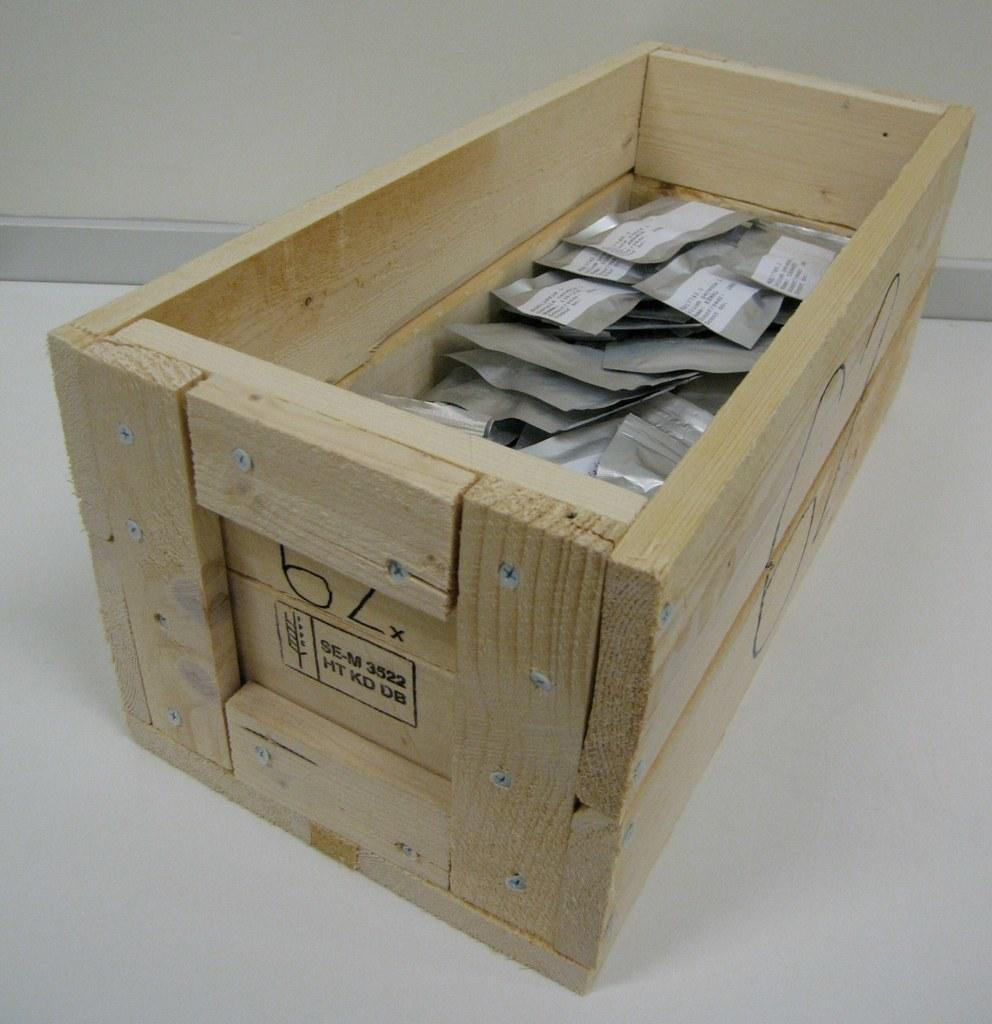<image>
Relay a brief, clear account of the picture shown. A wooden crate that is stamped with the identifier SE-M 3522, HT KD DB holds many foil packets. 